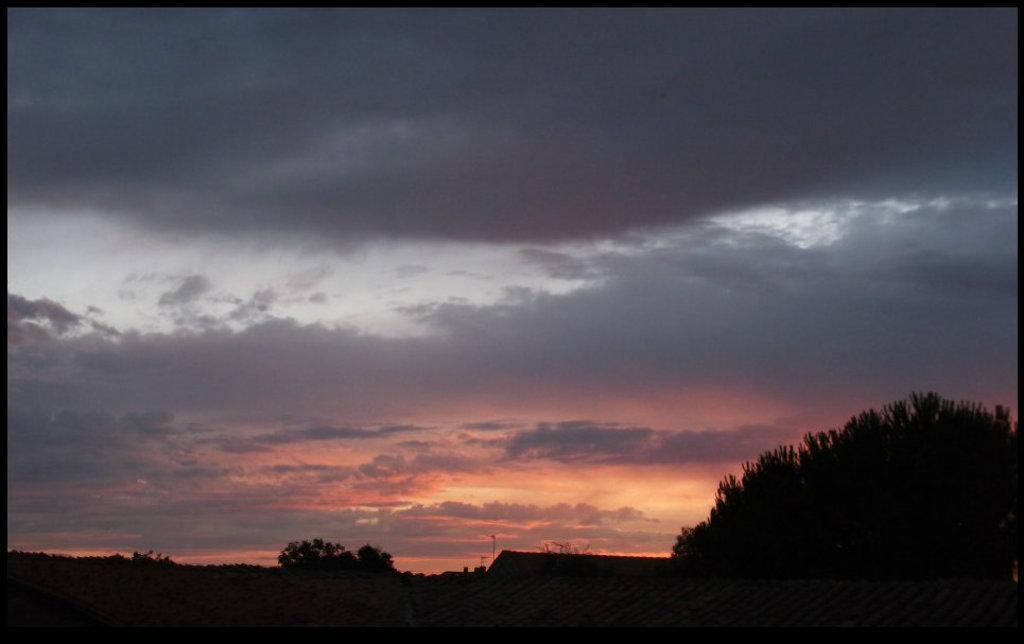What type of vegetation can be seen in the image? There are trees in the image. What is the condition of the sky in the image? The sky is cloudy in the image. What type of wool is being used to represent the trees in the image? There is no wool present in the image, and the trees are not represented by any material. 